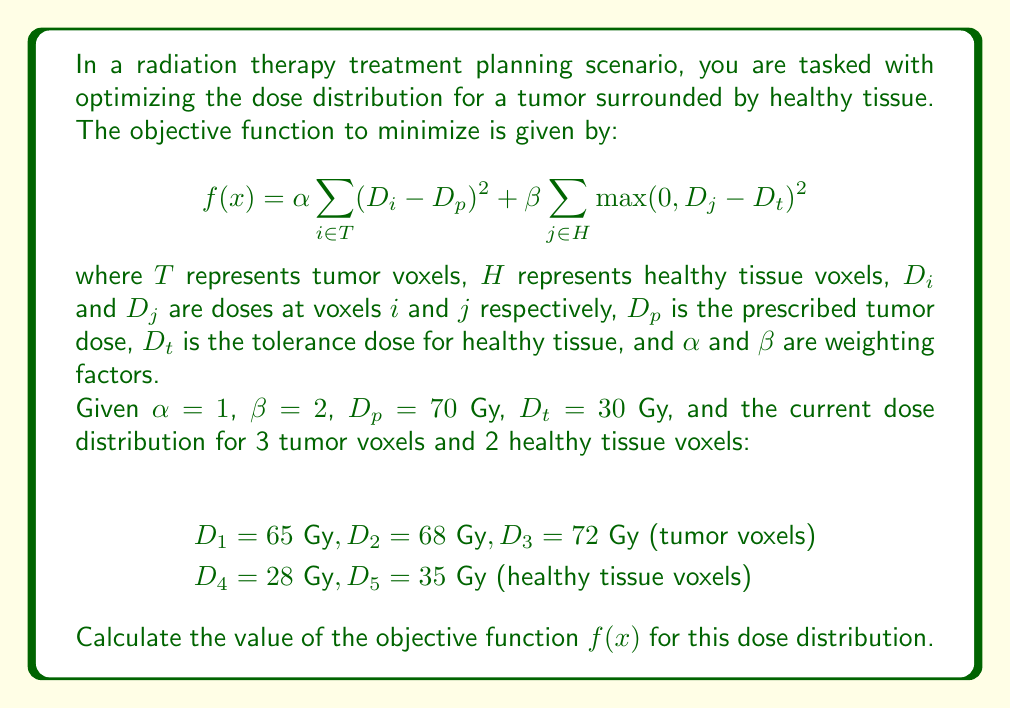Can you answer this question? To solve this problem, we need to evaluate the objective function using the given dose distribution. Let's break it down step by step:

1. For tumor voxels (first term of the objective function):
   $$\alpha \sum_{i \in T} (D_i - D_p)^2$$
   
   Calculate $(D_i - D_p)^2$ for each tumor voxel:
   $$(65 - 70)^2 = (-5)^2 = 25$$
   $$(68 - 70)^2 = (-2)^2 = 4$$
   $$(72 - 70)^2 = (2)^2 = 4$$
   
   Sum these values and multiply by $\alpha$:
   $$1 \cdot (25 + 4 + 4) = 33$$

2. For healthy tissue voxels (second term of the objective function):
   $$\beta \sum_{j \in H} \max(0, D_j - D_t)^2$$
   
   Calculate $\max(0, D_j - D_t)^2$ for each healthy tissue voxel:
   $$\max(0, 28 - 30)^2 = \max(0, -2)^2 = 0^2 = 0$$
   $$\max(0, 35 - 30)^2 = \max(0, 5)^2 = 5^2 = 25$$
   
   Sum these values and multiply by $\beta$:
   $$2 \cdot (0 + 25) = 50$$

3. Add the results from steps 1 and 2 to get the final value of $f(x)$:
   $$f(x) = 33 + 50 = 83$$

Therefore, the value of the objective function $f(x)$ for the given dose distribution is 83.
Answer: $f(x) = 83$ 